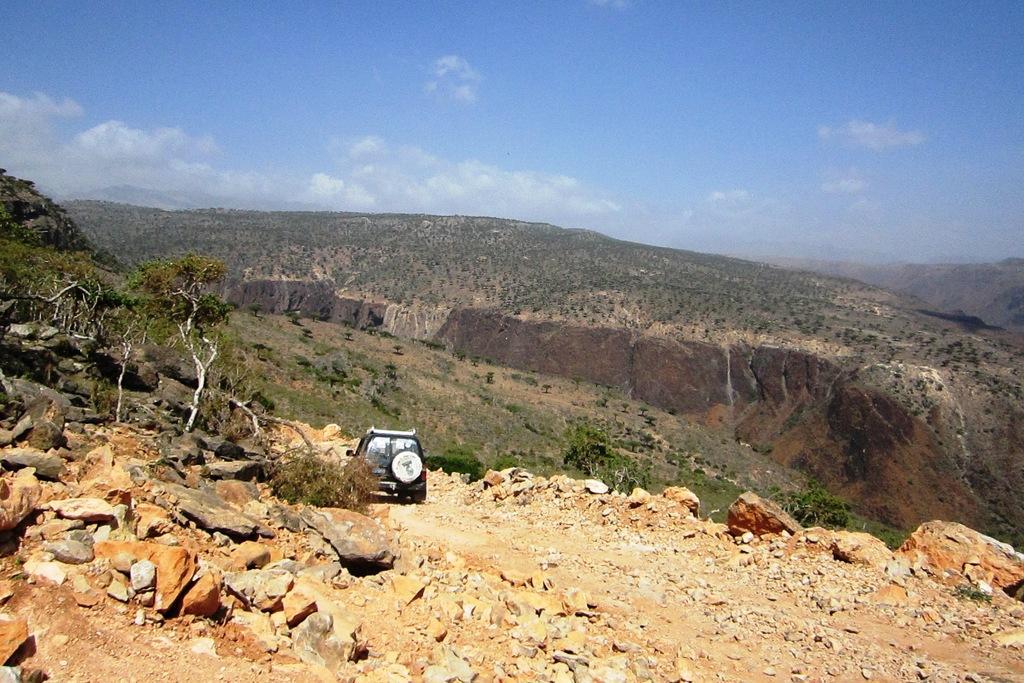How would you summarize this image in a sentence or two? In the background we can see the clouds in the sky. In this picture we can see the hills and thicket. We can see a vehicle, trees, stones and rocks. 